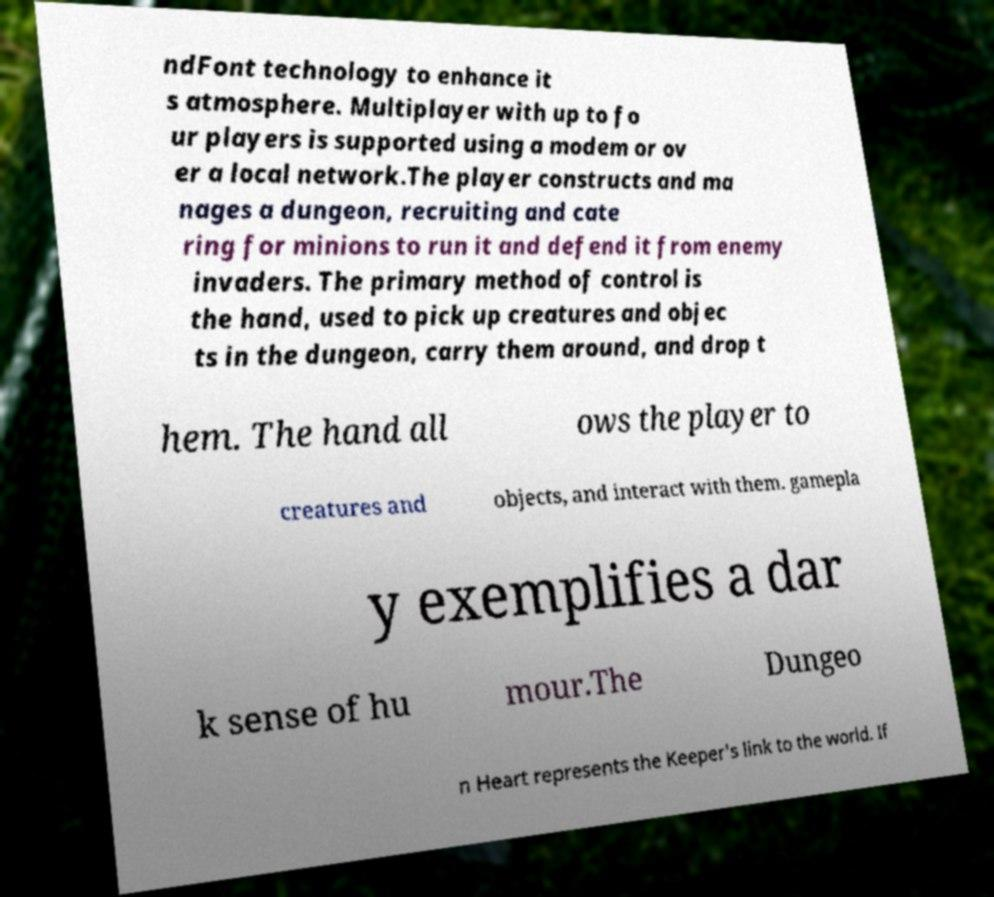There's text embedded in this image that I need extracted. Can you transcribe it verbatim? ndFont technology to enhance it s atmosphere. Multiplayer with up to fo ur players is supported using a modem or ov er a local network.The player constructs and ma nages a dungeon, recruiting and cate ring for minions to run it and defend it from enemy invaders. The primary method of control is the hand, used to pick up creatures and objec ts in the dungeon, carry them around, and drop t hem. The hand all ows the player to creatures and objects, and interact with them. gamepla y exemplifies a dar k sense of hu mour.The Dungeo n Heart represents the Keeper's link to the world. If 